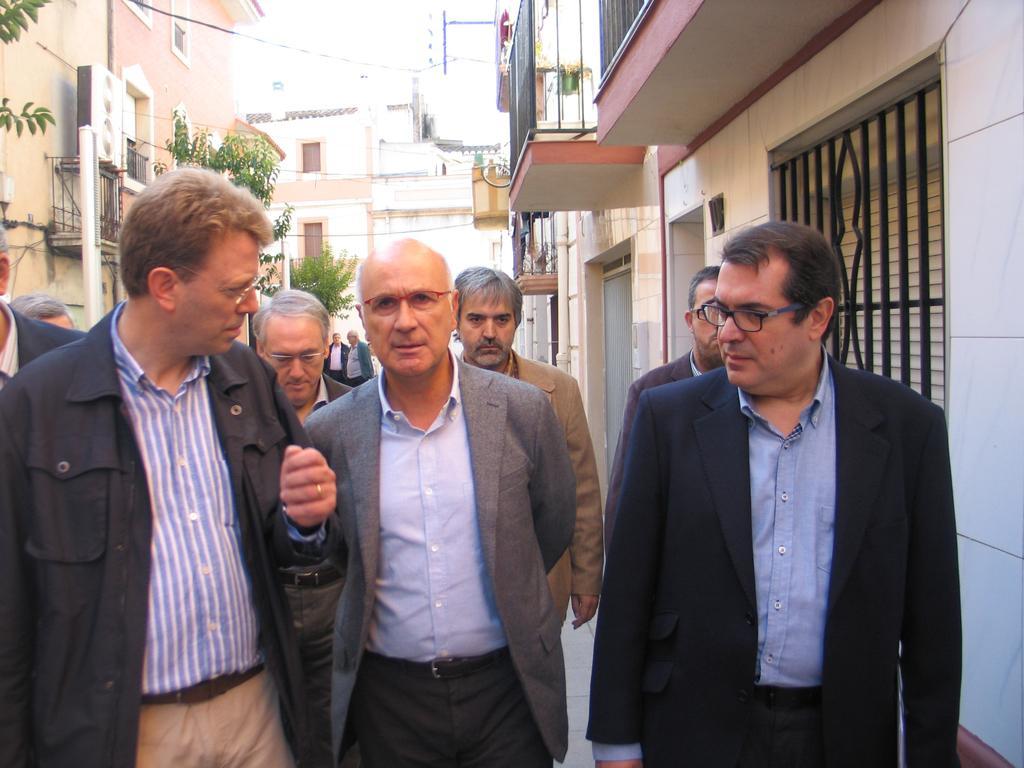Describe this image in one or two sentences. In the center of the image there are people. In the background of the image there are buildings. There are trees. 